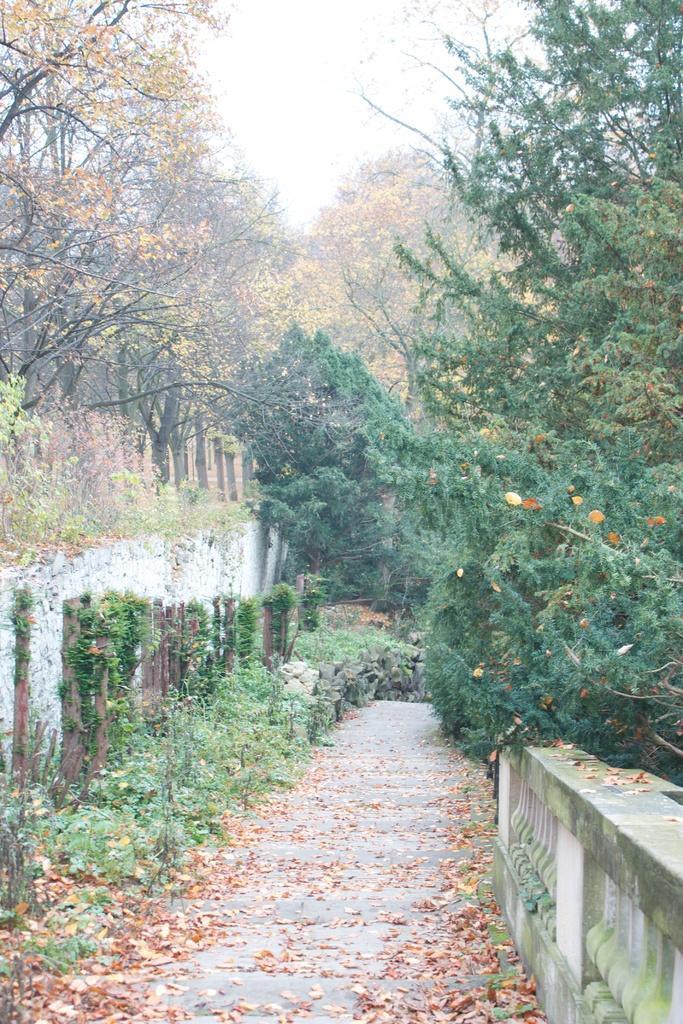Could you give a brief overview of what you see in this image? In this image we can see road, walls, plants, dried leaves, and trees. In the background there is sky. 